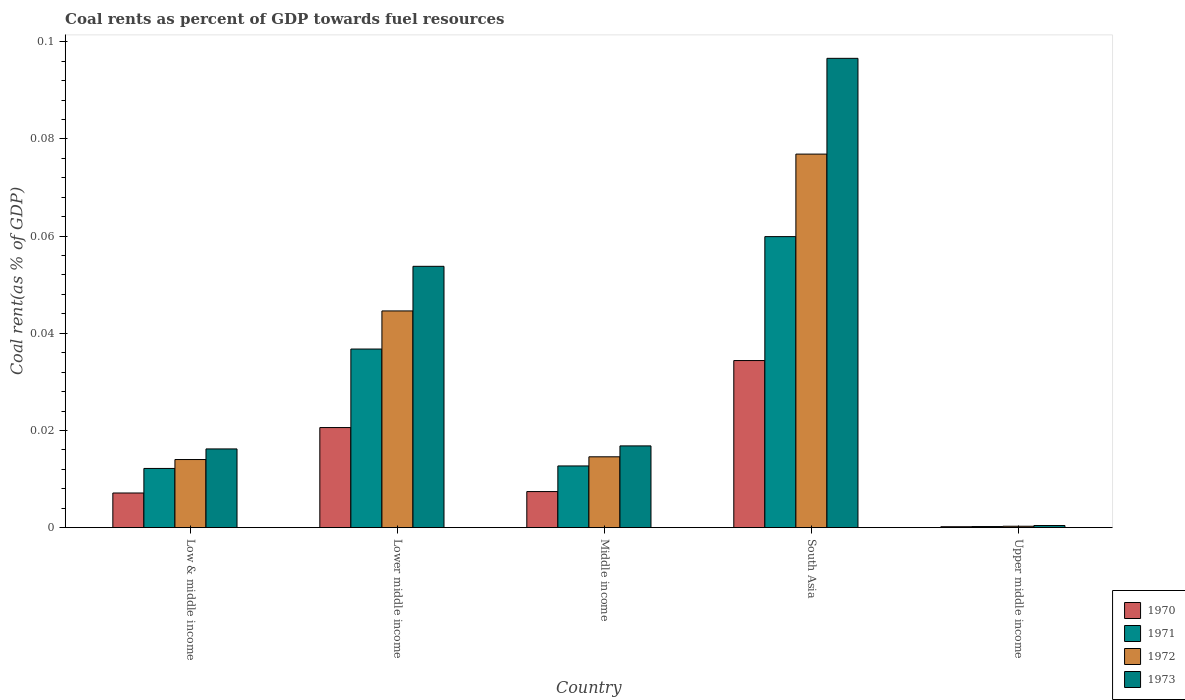How many bars are there on the 5th tick from the left?
Provide a succinct answer. 4. How many bars are there on the 5th tick from the right?
Keep it short and to the point. 4. What is the label of the 2nd group of bars from the left?
Your answer should be compact. Lower middle income. In how many cases, is the number of bars for a given country not equal to the number of legend labels?
Offer a terse response. 0. What is the coal rent in 1972 in Upper middle income?
Offer a very short reply. 0. Across all countries, what is the maximum coal rent in 1973?
Ensure brevity in your answer.  0.1. Across all countries, what is the minimum coal rent in 1973?
Keep it short and to the point. 0. In which country was the coal rent in 1970 maximum?
Your answer should be compact. South Asia. In which country was the coal rent in 1972 minimum?
Make the answer very short. Upper middle income. What is the total coal rent in 1973 in the graph?
Offer a terse response. 0.18. What is the difference between the coal rent in 1972 in Lower middle income and that in South Asia?
Ensure brevity in your answer.  -0.03. What is the difference between the coal rent in 1973 in Low & middle income and the coal rent in 1971 in Lower middle income?
Make the answer very short. -0.02. What is the average coal rent in 1972 per country?
Provide a succinct answer. 0.03. What is the difference between the coal rent of/in 1971 and coal rent of/in 1970 in Upper middle income?
Your answer should be compact. 3.4968209641675e-5. In how many countries, is the coal rent in 1973 greater than 0.08 %?
Your answer should be compact. 1. What is the ratio of the coal rent in 1972 in Low & middle income to that in South Asia?
Ensure brevity in your answer.  0.18. What is the difference between the highest and the second highest coal rent in 1973?
Your answer should be very brief. 0.08. What is the difference between the highest and the lowest coal rent in 1971?
Make the answer very short. 0.06. In how many countries, is the coal rent in 1970 greater than the average coal rent in 1970 taken over all countries?
Your answer should be compact. 2. Are all the bars in the graph horizontal?
Provide a succinct answer. No. What is the difference between two consecutive major ticks on the Y-axis?
Your response must be concise. 0.02. Does the graph contain grids?
Make the answer very short. No. Where does the legend appear in the graph?
Your answer should be compact. Bottom right. How many legend labels are there?
Offer a terse response. 4. What is the title of the graph?
Keep it short and to the point. Coal rents as percent of GDP towards fuel resources. What is the label or title of the X-axis?
Give a very brief answer. Country. What is the label or title of the Y-axis?
Provide a succinct answer. Coal rent(as % of GDP). What is the Coal rent(as % of GDP) of 1970 in Low & middle income?
Offer a terse response. 0.01. What is the Coal rent(as % of GDP) in 1971 in Low & middle income?
Ensure brevity in your answer.  0.01. What is the Coal rent(as % of GDP) of 1972 in Low & middle income?
Offer a terse response. 0.01. What is the Coal rent(as % of GDP) of 1973 in Low & middle income?
Offer a terse response. 0.02. What is the Coal rent(as % of GDP) in 1970 in Lower middle income?
Make the answer very short. 0.02. What is the Coal rent(as % of GDP) in 1971 in Lower middle income?
Provide a short and direct response. 0.04. What is the Coal rent(as % of GDP) of 1972 in Lower middle income?
Provide a short and direct response. 0.04. What is the Coal rent(as % of GDP) in 1973 in Lower middle income?
Provide a short and direct response. 0.05. What is the Coal rent(as % of GDP) of 1970 in Middle income?
Your answer should be compact. 0.01. What is the Coal rent(as % of GDP) in 1971 in Middle income?
Your response must be concise. 0.01. What is the Coal rent(as % of GDP) in 1972 in Middle income?
Your response must be concise. 0.01. What is the Coal rent(as % of GDP) in 1973 in Middle income?
Keep it short and to the point. 0.02. What is the Coal rent(as % of GDP) in 1970 in South Asia?
Make the answer very short. 0.03. What is the Coal rent(as % of GDP) of 1971 in South Asia?
Your response must be concise. 0.06. What is the Coal rent(as % of GDP) of 1972 in South Asia?
Offer a very short reply. 0.08. What is the Coal rent(as % of GDP) of 1973 in South Asia?
Your response must be concise. 0.1. What is the Coal rent(as % of GDP) in 1970 in Upper middle income?
Make the answer very short. 0. What is the Coal rent(as % of GDP) in 1971 in Upper middle income?
Your answer should be compact. 0. What is the Coal rent(as % of GDP) in 1972 in Upper middle income?
Provide a succinct answer. 0. What is the Coal rent(as % of GDP) of 1973 in Upper middle income?
Provide a succinct answer. 0. Across all countries, what is the maximum Coal rent(as % of GDP) of 1970?
Offer a terse response. 0.03. Across all countries, what is the maximum Coal rent(as % of GDP) in 1971?
Offer a terse response. 0.06. Across all countries, what is the maximum Coal rent(as % of GDP) of 1972?
Ensure brevity in your answer.  0.08. Across all countries, what is the maximum Coal rent(as % of GDP) of 1973?
Ensure brevity in your answer.  0.1. Across all countries, what is the minimum Coal rent(as % of GDP) in 1970?
Keep it short and to the point. 0. Across all countries, what is the minimum Coal rent(as % of GDP) in 1971?
Provide a short and direct response. 0. Across all countries, what is the minimum Coal rent(as % of GDP) of 1972?
Make the answer very short. 0. Across all countries, what is the minimum Coal rent(as % of GDP) of 1973?
Offer a very short reply. 0. What is the total Coal rent(as % of GDP) in 1970 in the graph?
Keep it short and to the point. 0.07. What is the total Coal rent(as % of GDP) of 1971 in the graph?
Offer a very short reply. 0.12. What is the total Coal rent(as % of GDP) in 1972 in the graph?
Keep it short and to the point. 0.15. What is the total Coal rent(as % of GDP) in 1973 in the graph?
Offer a very short reply. 0.18. What is the difference between the Coal rent(as % of GDP) in 1970 in Low & middle income and that in Lower middle income?
Offer a very short reply. -0.01. What is the difference between the Coal rent(as % of GDP) of 1971 in Low & middle income and that in Lower middle income?
Ensure brevity in your answer.  -0.02. What is the difference between the Coal rent(as % of GDP) in 1972 in Low & middle income and that in Lower middle income?
Ensure brevity in your answer.  -0.03. What is the difference between the Coal rent(as % of GDP) of 1973 in Low & middle income and that in Lower middle income?
Ensure brevity in your answer.  -0.04. What is the difference between the Coal rent(as % of GDP) in 1970 in Low & middle income and that in Middle income?
Offer a very short reply. -0. What is the difference between the Coal rent(as % of GDP) of 1971 in Low & middle income and that in Middle income?
Your response must be concise. -0. What is the difference between the Coal rent(as % of GDP) of 1972 in Low & middle income and that in Middle income?
Give a very brief answer. -0. What is the difference between the Coal rent(as % of GDP) of 1973 in Low & middle income and that in Middle income?
Your answer should be compact. -0. What is the difference between the Coal rent(as % of GDP) in 1970 in Low & middle income and that in South Asia?
Ensure brevity in your answer.  -0.03. What is the difference between the Coal rent(as % of GDP) in 1971 in Low & middle income and that in South Asia?
Offer a very short reply. -0.05. What is the difference between the Coal rent(as % of GDP) of 1972 in Low & middle income and that in South Asia?
Provide a short and direct response. -0.06. What is the difference between the Coal rent(as % of GDP) of 1973 in Low & middle income and that in South Asia?
Offer a terse response. -0.08. What is the difference between the Coal rent(as % of GDP) of 1970 in Low & middle income and that in Upper middle income?
Offer a very short reply. 0.01. What is the difference between the Coal rent(as % of GDP) of 1971 in Low & middle income and that in Upper middle income?
Give a very brief answer. 0.01. What is the difference between the Coal rent(as % of GDP) of 1972 in Low & middle income and that in Upper middle income?
Give a very brief answer. 0.01. What is the difference between the Coal rent(as % of GDP) of 1973 in Low & middle income and that in Upper middle income?
Make the answer very short. 0.02. What is the difference between the Coal rent(as % of GDP) in 1970 in Lower middle income and that in Middle income?
Provide a succinct answer. 0.01. What is the difference between the Coal rent(as % of GDP) in 1971 in Lower middle income and that in Middle income?
Offer a very short reply. 0.02. What is the difference between the Coal rent(as % of GDP) in 1973 in Lower middle income and that in Middle income?
Offer a very short reply. 0.04. What is the difference between the Coal rent(as % of GDP) in 1970 in Lower middle income and that in South Asia?
Give a very brief answer. -0.01. What is the difference between the Coal rent(as % of GDP) of 1971 in Lower middle income and that in South Asia?
Your answer should be compact. -0.02. What is the difference between the Coal rent(as % of GDP) of 1972 in Lower middle income and that in South Asia?
Your answer should be compact. -0.03. What is the difference between the Coal rent(as % of GDP) in 1973 in Lower middle income and that in South Asia?
Make the answer very short. -0.04. What is the difference between the Coal rent(as % of GDP) in 1970 in Lower middle income and that in Upper middle income?
Make the answer very short. 0.02. What is the difference between the Coal rent(as % of GDP) in 1971 in Lower middle income and that in Upper middle income?
Give a very brief answer. 0.04. What is the difference between the Coal rent(as % of GDP) of 1972 in Lower middle income and that in Upper middle income?
Keep it short and to the point. 0.04. What is the difference between the Coal rent(as % of GDP) of 1973 in Lower middle income and that in Upper middle income?
Ensure brevity in your answer.  0.05. What is the difference between the Coal rent(as % of GDP) of 1970 in Middle income and that in South Asia?
Provide a short and direct response. -0.03. What is the difference between the Coal rent(as % of GDP) in 1971 in Middle income and that in South Asia?
Give a very brief answer. -0.05. What is the difference between the Coal rent(as % of GDP) in 1972 in Middle income and that in South Asia?
Make the answer very short. -0.06. What is the difference between the Coal rent(as % of GDP) in 1973 in Middle income and that in South Asia?
Offer a terse response. -0.08. What is the difference between the Coal rent(as % of GDP) in 1970 in Middle income and that in Upper middle income?
Keep it short and to the point. 0.01. What is the difference between the Coal rent(as % of GDP) of 1971 in Middle income and that in Upper middle income?
Keep it short and to the point. 0.01. What is the difference between the Coal rent(as % of GDP) of 1972 in Middle income and that in Upper middle income?
Offer a very short reply. 0.01. What is the difference between the Coal rent(as % of GDP) in 1973 in Middle income and that in Upper middle income?
Your answer should be very brief. 0.02. What is the difference between the Coal rent(as % of GDP) in 1970 in South Asia and that in Upper middle income?
Give a very brief answer. 0.03. What is the difference between the Coal rent(as % of GDP) of 1971 in South Asia and that in Upper middle income?
Offer a terse response. 0.06. What is the difference between the Coal rent(as % of GDP) in 1972 in South Asia and that in Upper middle income?
Provide a succinct answer. 0.08. What is the difference between the Coal rent(as % of GDP) of 1973 in South Asia and that in Upper middle income?
Your answer should be compact. 0.1. What is the difference between the Coal rent(as % of GDP) in 1970 in Low & middle income and the Coal rent(as % of GDP) in 1971 in Lower middle income?
Your response must be concise. -0.03. What is the difference between the Coal rent(as % of GDP) in 1970 in Low & middle income and the Coal rent(as % of GDP) in 1972 in Lower middle income?
Your answer should be very brief. -0.04. What is the difference between the Coal rent(as % of GDP) of 1970 in Low & middle income and the Coal rent(as % of GDP) of 1973 in Lower middle income?
Offer a terse response. -0.05. What is the difference between the Coal rent(as % of GDP) in 1971 in Low & middle income and the Coal rent(as % of GDP) in 1972 in Lower middle income?
Provide a succinct answer. -0.03. What is the difference between the Coal rent(as % of GDP) of 1971 in Low & middle income and the Coal rent(as % of GDP) of 1973 in Lower middle income?
Provide a short and direct response. -0.04. What is the difference between the Coal rent(as % of GDP) in 1972 in Low & middle income and the Coal rent(as % of GDP) in 1973 in Lower middle income?
Offer a terse response. -0.04. What is the difference between the Coal rent(as % of GDP) in 1970 in Low & middle income and the Coal rent(as % of GDP) in 1971 in Middle income?
Offer a terse response. -0.01. What is the difference between the Coal rent(as % of GDP) of 1970 in Low & middle income and the Coal rent(as % of GDP) of 1972 in Middle income?
Keep it short and to the point. -0.01. What is the difference between the Coal rent(as % of GDP) of 1970 in Low & middle income and the Coal rent(as % of GDP) of 1973 in Middle income?
Give a very brief answer. -0.01. What is the difference between the Coal rent(as % of GDP) of 1971 in Low & middle income and the Coal rent(as % of GDP) of 1972 in Middle income?
Your answer should be very brief. -0. What is the difference between the Coal rent(as % of GDP) of 1971 in Low & middle income and the Coal rent(as % of GDP) of 1973 in Middle income?
Offer a terse response. -0. What is the difference between the Coal rent(as % of GDP) in 1972 in Low & middle income and the Coal rent(as % of GDP) in 1973 in Middle income?
Provide a short and direct response. -0. What is the difference between the Coal rent(as % of GDP) of 1970 in Low & middle income and the Coal rent(as % of GDP) of 1971 in South Asia?
Provide a succinct answer. -0.05. What is the difference between the Coal rent(as % of GDP) in 1970 in Low & middle income and the Coal rent(as % of GDP) in 1972 in South Asia?
Keep it short and to the point. -0.07. What is the difference between the Coal rent(as % of GDP) of 1970 in Low & middle income and the Coal rent(as % of GDP) of 1973 in South Asia?
Provide a succinct answer. -0.09. What is the difference between the Coal rent(as % of GDP) of 1971 in Low & middle income and the Coal rent(as % of GDP) of 1972 in South Asia?
Offer a very short reply. -0.06. What is the difference between the Coal rent(as % of GDP) in 1971 in Low & middle income and the Coal rent(as % of GDP) in 1973 in South Asia?
Provide a succinct answer. -0.08. What is the difference between the Coal rent(as % of GDP) of 1972 in Low & middle income and the Coal rent(as % of GDP) of 1973 in South Asia?
Your answer should be very brief. -0.08. What is the difference between the Coal rent(as % of GDP) of 1970 in Low & middle income and the Coal rent(as % of GDP) of 1971 in Upper middle income?
Give a very brief answer. 0.01. What is the difference between the Coal rent(as % of GDP) of 1970 in Low & middle income and the Coal rent(as % of GDP) of 1972 in Upper middle income?
Make the answer very short. 0.01. What is the difference between the Coal rent(as % of GDP) in 1970 in Low & middle income and the Coal rent(as % of GDP) in 1973 in Upper middle income?
Ensure brevity in your answer.  0.01. What is the difference between the Coal rent(as % of GDP) of 1971 in Low & middle income and the Coal rent(as % of GDP) of 1972 in Upper middle income?
Make the answer very short. 0.01. What is the difference between the Coal rent(as % of GDP) in 1971 in Low & middle income and the Coal rent(as % of GDP) in 1973 in Upper middle income?
Ensure brevity in your answer.  0.01. What is the difference between the Coal rent(as % of GDP) of 1972 in Low & middle income and the Coal rent(as % of GDP) of 1973 in Upper middle income?
Keep it short and to the point. 0.01. What is the difference between the Coal rent(as % of GDP) in 1970 in Lower middle income and the Coal rent(as % of GDP) in 1971 in Middle income?
Your answer should be compact. 0.01. What is the difference between the Coal rent(as % of GDP) of 1970 in Lower middle income and the Coal rent(as % of GDP) of 1972 in Middle income?
Make the answer very short. 0.01. What is the difference between the Coal rent(as % of GDP) in 1970 in Lower middle income and the Coal rent(as % of GDP) in 1973 in Middle income?
Give a very brief answer. 0. What is the difference between the Coal rent(as % of GDP) of 1971 in Lower middle income and the Coal rent(as % of GDP) of 1972 in Middle income?
Provide a succinct answer. 0.02. What is the difference between the Coal rent(as % of GDP) in 1971 in Lower middle income and the Coal rent(as % of GDP) in 1973 in Middle income?
Your answer should be very brief. 0.02. What is the difference between the Coal rent(as % of GDP) in 1972 in Lower middle income and the Coal rent(as % of GDP) in 1973 in Middle income?
Your answer should be very brief. 0.03. What is the difference between the Coal rent(as % of GDP) of 1970 in Lower middle income and the Coal rent(as % of GDP) of 1971 in South Asia?
Make the answer very short. -0.04. What is the difference between the Coal rent(as % of GDP) of 1970 in Lower middle income and the Coal rent(as % of GDP) of 1972 in South Asia?
Ensure brevity in your answer.  -0.06. What is the difference between the Coal rent(as % of GDP) of 1970 in Lower middle income and the Coal rent(as % of GDP) of 1973 in South Asia?
Offer a terse response. -0.08. What is the difference between the Coal rent(as % of GDP) of 1971 in Lower middle income and the Coal rent(as % of GDP) of 1972 in South Asia?
Your answer should be compact. -0.04. What is the difference between the Coal rent(as % of GDP) in 1971 in Lower middle income and the Coal rent(as % of GDP) in 1973 in South Asia?
Provide a short and direct response. -0.06. What is the difference between the Coal rent(as % of GDP) of 1972 in Lower middle income and the Coal rent(as % of GDP) of 1973 in South Asia?
Offer a terse response. -0.05. What is the difference between the Coal rent(as % of GDP) in 1970 in Lower middle income and the Coal rent(as % of GDP) in 1971 in Upper middle income?
Your answer should be very brief. 0.02. What is the difference between the Coal rent(as % of GDP) in 1970 in Lower middle income and the Coal rent(as % of GDP) in 1972 in Upper middle income?
Offer a terse response. 0.02. What is the difference between the Coal rent(as % of GDP) in 1970 in Lower middle income and the Coal rent(as % of GDP) in 1973 in Upper middle income?
Your answer should be compact. 0.02. What is the difference between the Coal rent(as % of GDP) in 1971 in Lower middle income and the Coal rent(as % of GDP) in 1972 in Upper middle income?
Ensure brevity in your answer.  0.04. What is the difference between the Coal rent(as % of GDP) of 1971 in Lower middle income and the Coal rent(as % of GDP) of 1973 in Upper middle income?
Ensure brevity in your answer.  0.04. What is the difference between the Coal rent(as % of GDP) of 1972 in Lower middle income and the Coal rent(as % of GDP) of 1973 in Upper middle income?
Give a very brief answer. 0.04. What is the difference between the Coal rent(as % of GDP) in 1970 in Middle income and the Coal rent(as % of GDP) in 1971 in South Asia?
Your response must be concise. -0.05. What is the difference between the Coal rent(as % of GDP) in 1970 in Middle income and the Coal rent(as % of GDP) in 1972 in South Asia?
Make the answer very short. -0.07. What is the difference between the Coal rent(as % of GDP) of 1970 in Middle income and the Coal rent(as % of GDP) of 1973 in South Asia?
Your answer should be compact. -0.09. What is the difference between the Coal rent(as % of GDP) in 1971 in Middle income and the Coal rent(as % of GDP) in 1972 in South Asia?
Provide a short and direct response. -0.06. What is the difference between the Coal rent(as % of GDP) of 1971 in Middle income and the Coal rent(as % of GDP) of 1973 in South Asia?
Ensure brevity in your answer.  -0.08. What is the difference between the Coal rent(as % of GDP) of 1972 in Middle income and the Coal rent(as % of GDP) of 1973 in South Asia?
Offer a terse response. -0.08. What is the difference between the Coal rent(as % of GDP) in 1970 in Middle income and the Coal rent(as % of GDP) in 1971 in Upper middle income?
Your answer should be very brief. 0.01. What is the difference between the Coal rent(as % of GDP) in 1970 in Middle income and the Coal rent(as % of GDP) in 1972 in Upper middle income?
Provide a short and direct response. 0.01. What is the difference between the Coal rent(as % of GDP) in 1970 in Middle income and the Coal rent(as % of GDP) in 1973 in Upper middle income?
Ensure brevity in your answer.  0.01. What is the difference between the Coal rent(as % of GDP) in 1971 in Middle income and the Coal rent(as % of GDP) in 1972 in Upper middle income?
Your answer should be compact. 0.01. What is the difference between the Coal rent(as % of GDP) of 1971 in Middle income and the Coal rent(as % of GDP) of 1973 in Upper middle income?
Make the answer very short. 0.01. What is the difference between the Coal rent(as % of GDP) of 1972 in Middle income and the Coal rent(as % of GDP) of 1973 in Upper middle income?
Provide a short and direct response. 0.01. What is the difference between the Coal rent(as % of GDP) in 1970 in South Asia and the Coal rent(as % of GDP) in 1971 in Upper middle income?
Your answer should be compact. 0.03. What is the difference between the Coal rent(as % of GDP) in 1970 in South Asia and the Coal rent(as % of GDP) in 1972 in Upper middle income?
Provide a short and direct response. 0.03. What is the difference between the Coal rent(as % of GDP) of 1970 in South Asia and the Coal rent(as % of GDP) of 1973 in Upper middle income?
Your response must be concise. 0.03. What is the difference between the Coal rent(as % of GDP) of 1971 in South Asia and the Coal rent(as % of GDP) of 1972 in Upper middle income?
Your response must be concise. 0.06. What is the difference between the Coal rent(as % of GDP) in 1971 in South Asia and the Coal rent(as % of GDP) in 1973 in Upper middle income?
Provide a short and direct response. 0.06. What is the difference between the Coal rent(as % of GDP) in 1972 in South Asia and the Coal rent(as % of GDP) in 1973 in Upper middle income?
Provide a short and direct response. 0.08. What is the average Coal rent(as % of GDP) of 1970 per country?
Ensure brevity in your answer.  0.01. What is the average Coal rent(as % of GDP) of 1971 per country?
Give a very brief answer. 0.02. What is the average Coal rent(as % of GDP) in 1972 per country?
Ensure brevity in your answer.  0.03. What is the average Coal rent(as % of GDP) in 1973 per country?
Give a very brief answer. 0.04. What is the difference between the Coal rent(as % of GDP) of 1970 and Coal rent(as % of GDP) of 1971 in Low & middle income?
Offer a terse response. -0.01. What is the difference between the Coal rent(as % of GDP) of 1970 and Coal rent(as % of GDP) of 1972 in Low & middle income?
Offer a very short reply. -0.01. What is the difference between the Coal rent(as % of GDP) in 1970 and Coal rent(as % of GDP) in 1973 in Low & middle income?
Your response must be concise. -0.01. What is the difference between the Coal rent(as % of GDP) in 1971 and Coal rent(as % of GDP) in 1972 in Low & middle income?
Your response must be concise. -0. What is the difference between the Coal rent(as % of GDP) in 1971 and Coal rent(as % of GDP) in 1973 in Low & middle income?
Provide a short and direct response. -0. What is the difference between the Coal rent(as % of GDP) of 1972 and Coal rent(as % of GDP) of 1973 in Low & middle income?
Make the answer very short. -0. What is the difference between the Coal rent(as % of GDP) in 1970 and Coal rent(as % of GDP) in 1971 in Lower middle income?
Provide a succinct answer. -0.02. What is the difference between the Coal rent(as % of GDP) of 1970 and Coal rent(as % of GDP) of 1972 in Lower middle income?
Your response must be concise. -0.02. What is the difference between the Coal rent(as % of GDP) in 1970 and Coal rent(as % of GDP) in 1973 in Lower middle income?
Keep it short and to the point. -0.03. What is the difference between the Coal rent(as % of GDP) of 1971 and Coal rent(as % of GDP) of 1972 in Lower middle income?
Your answer should be compact. -0.01. What is the difference between the Coal rent(as % of GDP) of 1971 and Coal rent(as % of GDP) of 1973 in Lower middle income?
Your response must be concise. -0.02. What is the difference between the Coal rent(as % of GDP) of 1972 and Coal rent(as % of GDP) of 1973 in Lower middle income?
Ensure brevity in your answer.  -0.01. What is the difference between the Coal rent(as % of GDP) of 1970 and Coal rent(as % of GDP) of 1971 in Middle income?
Keep it short and to the point. -0.01. What is the difference between the Coal rent(as % of GDP) of 1970 and Coal rent(as % of GDP) of 1972 in Middle income?
Offer a terse response. -0.01. What is the difference between the Coal rent(as % of GDP) in 1970 and Coal rent(as % of GDP) in 1973 in Middle income?
Offer a terse response. -0.01. What is the difference between the Coal rent(as % of GDP) of 1971 and Coal rent(as % of GDP) of 1972 in Middle income?
Offer a terse response. -0. What is the difference between the Coal rent(as % of GDP) of 1971 and Coal rent(as % of GDP) of 1973 in Middle income?
Provide a short and direct response. -0. What is the difference between the Coal rent(as % of GDP) of 1972 and Coal rent(as % of GDP) of 1973 in Middle income?
Provide a succinct answer. -0. What is the difference between the Coal rent(as % of GDP) in 1970 and Coal rent(as % of GDP) in 1971 in South Asia?
Your answer should be compact. -0.03. What is the difference between the Coal rent(as % of GDP) in 1970 and Coal rent(as % of GDP) in 1972 in South Asia?
Make the answer very short. -0.04. What is the difference between the Coal rent(as % of GDP) in 1970 and Coal rent(as % of GDP) in 1973 in South Asia?
Offer a terse response. -0.06. What is the difference between the Coal rent(as % of GDP) of 1971 and Coal rent(as % of GDP) of 1972 in South Asia?
Ensure brevity in your answer.  -0.02. What is the difference between the Coal rent(as % of GDP) in 1971 and Coal rent(as % of GDP) in 1973 in South Asia?
Give a very brief answer. -0.04. What is the difference between the Coal rent(as % of GDP) of 1972 and Coal rent(as % of GDP) of 1973 in South Asia?
Keep it short and to the point. -0.02. What is the difference between the Coal rent(as % of GDP) in 1970 and Coal rent(as % of GDP) in 1971 in Upper middle income?
Keep it short and to the point. -0. What is the difference between the Coal rent(as % of GDP) in 1970 and Coal rent(as % of GDP) in 1972 in Upper middle income?
Keep it short and to the point. -0. What is the difference between the Coal rent(as % of GDP) of 1970 and Coal rent(as % of GDP) of 1973 in Upper middle income?
Your answer should be very brief. -0. What is the difference between the Coal rent(as % of GDP) in 1971 and Coal rent(as % of GDP) in 1972 in Upper middle income?
Provide a succinct answer. -0. What is the difference between the Coal rent(as % of GDP) of 1971 and Coal rent(as % of GDP) of 1973 in Upper middle income?
Give a very brief answer. -0. What is the difference between the Coal rent(as % of GDP) in 1972 and Coal rent(as % of GDP) in 1973 in Upper middle income?
Offer a terse response. -0. What is the ratio of the Coal rent(as % of GDP) of 1970 in Low & middle income to that in Lower middle income?
Give a very brief answer. 0.35. What is the ratio of the Coal rent(as % of GDP) in 1971 in Low & middle income to that in Lower middle income?
Ensure brevity in your answer.  0.33. What is the ratio of the Coal rent(as % of GDP) in 1972 in Low & middle income to that in Lower middle income?
Your response must be concise. 0.31. What is the ratio of the Coal rent(as % of GDP) of 1973 in Low & middle income to that in Lower middle income?
Keep it short and to the point. 0.3. What is the ratio of the Coal rent(as % of GDP) in 1970 in Low & middle income to that in Middle income?
Offer a very short reply. 0.96. What is the ratio of the Coal rent(as % of GDP) in 1971 in Low & middle income to that in Middle income?
Offer a very short reply. 0.96. What is the ratio of the Coal rent(as % of GDP) in 1972 in Low & middle income to that in Middle income?
Keep it short and to the point. 0.96. What is the ratio of the Coal rent(as % of GDP) of 1973 in Low & middle income to that in Middle income?
Your response must be concise. 0.96. What is the ratio of the Coal rent(as % of GDP) in 1970 in Low & middle income to that in South Asia?
Offer a very short reply. 0.21. What is the ratio of the Coal rent(as % of GDP) in 1971 in Low & middle income to that in South Asia?
Offer a very short reply. 0.2. What is the ratio of the Coal rent(as % of GDP) in 1972 in Low & middle income to that in South Asia?
Provide a short and direct response. 0.18. What is the ratio of the Coal rent(as % of GDP) in 1973 in Low & middle income to that in South Asia?
Your response must be concise. 0.17. What is the ratio of the Coal rent(as % of GDP) of 1970 in Low & middle income to that in Upper middle income?
Provide a short and direct response. 38.77. What is the ratio of the Coal rent(as % of GDP) in 1971 in Low & middle income to that in Upper middle income?
Offer a terse response. 55.66. What is the ratio of the Coal rent(as % of GDP) in 1972 in Low & middle income to that in Upper middle income?
Offer a terse response. 49.28. What is the ratio of the Coal rent(as % of GDP) in 1973 in Low & middle income to that in Upper middle income?
Offer a very short reply. 37.59. What is the ratio of the Coal rent(as % of GDP) in 1970 in Lower middle income to that in Middle income?
Provide a succinct answer. 2.78. What is the ratio of the Coal rent(as % of GDP) of 1971 in Lower middle income to that in Middle income?
Keep it short and to the point. 2.9. What is the ratio of the Coal rent(as % of GDP) of 1972 in Lower middle income to that in Middle income?
Make the answer very short. 3.06. What is the ratio of the Coal rent(as % of GDP) of 1973 in Lower middle income to that in Middle income?
Ensure brevity in your answer.  3.2. What is the ratio of the Coal rent(as % of GDP) in 1970 in Lower middle income to that in South Asia?
Your answer should be very brief. 0.6. What is the ratio of the Coal rent(as % of GDP) in 1971 in Lower middle income to that in South Asia?
Ensure brevity in your answer.  0.61. What is the ratio of the Coal rent(as % of GDP) of 1972 in Lower middle income to that in South Asia?
Your answer should be very brief. 0.58. What is the ratio of the Coal rent(as % of GDP) in 1973 in Lower middle income to that in South Asia?
Offer a terse response. 0.56. What is the ratio of the Coal rent(as % of GDP) in 1970 in Lower middle income to that in Upper middle income?
Provide a succinct answer. 112.03. What is the ratio of the Coal rent(as % of GDP) of 1971 in Lower middle income to that in Upper middle income?
Offer a terse response. 167.98. What is the ratio of the Coal rent(as % of GDP) of 1972 in Lower middle income to that in Upper middle income?
Offer a terse response. 156.82. What is the ratio of the Coal rent(as % of GDP) in 1973 in Lower middle income to that in Upper middle income?
Keep it short and to the point. 124.82. What is the ratio of the Coal rent(as % of GDP) in 1970 in Middle income to that in South Asia?
Ensure brevity in your answer.  0.22. What is the ratio of the Coal rent(as % of GDP) in 1971 in Middle income to that in South Asia?
Your response must be concise. 0.21. What is the ratio of the Coal rent(as % of GDP) in 1972 in Middle income to that in South Asia?
Offer a terse response. 0.19. What is the ratio of the Coal rent(as % of GDP) of 1973 in Middle income to that in South Asia?
Make the answer very short. 0.17. What is the ratio of the Coal rent(as % of GDP) of 1970 in Middle income to that in Upper middle income?
Provide a short and direct response. 40.36. What is the ratio of the Coal rent(as % of GDP) of 1971 in Middle income to that in Upper middle income?
Give a very brief answer. 58.01. What is the ratio of the Coal rent(as % of GDP) in 1972 in Middle income to that in Upper middle income?
Make the answer very short. 51.25. What is the ratio of the Coal rent(as % of GDP) of 1973 in Middle income to that in Upper middle income?
Provide a short and direct response. 39.04. What is the ratio of the Coal rent(as % of GDP) of 1970 in South Asia to that in Upper middle income?
Your response must be concise. 187.05. What is the ratio of the Coal rent(as % of GDP) in 1971 in South Asia to that in Upper middle income?
Ensure brevity in your answer.  273.74. What is the ratio of the Coal rent(as % of GDP) of 1972 in South Asia to that in Upper middle income?
Your answer should be compact. 270.32. What is the ratio of the Coal rent(as % of GDP) of 1973 in South Asia to that in Upper middle income?
Provide a short and direct response. 224.18. What is the difference between the highest and the second highest Coal rent(as % of GDP) in 1970?
Your response must be concise. 0.01. What is the difference between the highest and the second highest Coal rent(as % of GDP) in 1971?
Give a very brief answer. 0.02. What is the difference between the highest and the second highest Coal rent(as % of GDP) of 1972?
Your answer should be compact. 0.03. What is the difference between the highest and the second highest Coal rent(as % of GDP) of 1973?
Offer a very short reply. 0.04. What is the difference between the highest and the lowest Coal rent(as % of GDP) of 1970?
Give a very brief answer. 0.03. What is the difference between the highest and the lowest Coal rent(as % of GDP) in 1971?
Offer a very short reply. 0.06. What is the difference between the highest and the lowest Coal rent(as % of GDP) in 1972?
Offer a very short reply. 0.08. What is the difference between the highest and the lowest Coal rent(as % of GDP) of 1973?
Make the answer very short. 0.1. 